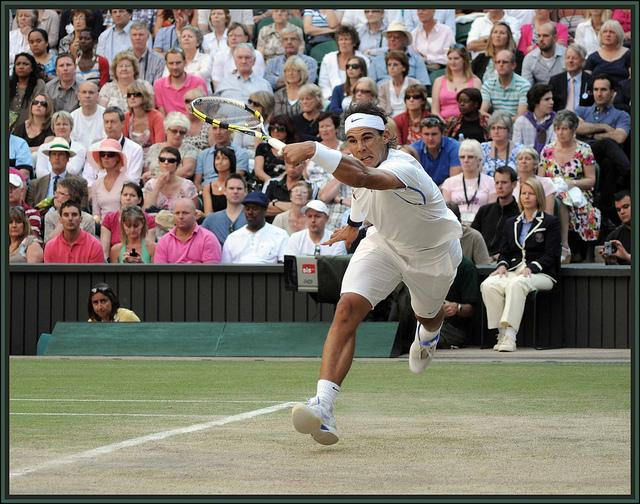What is the player's facial expression?

Choices:
A) disgusted
B) focused
C) angry
D) painful focused 